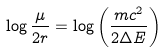<formula> <loc_0><loc_0><loc_500><loc_500>\log \frac { \mu } { 2 r } = \log \left ( \frac { m c ^ { 2 } } { 2 \Delta E } \right )</formula> 